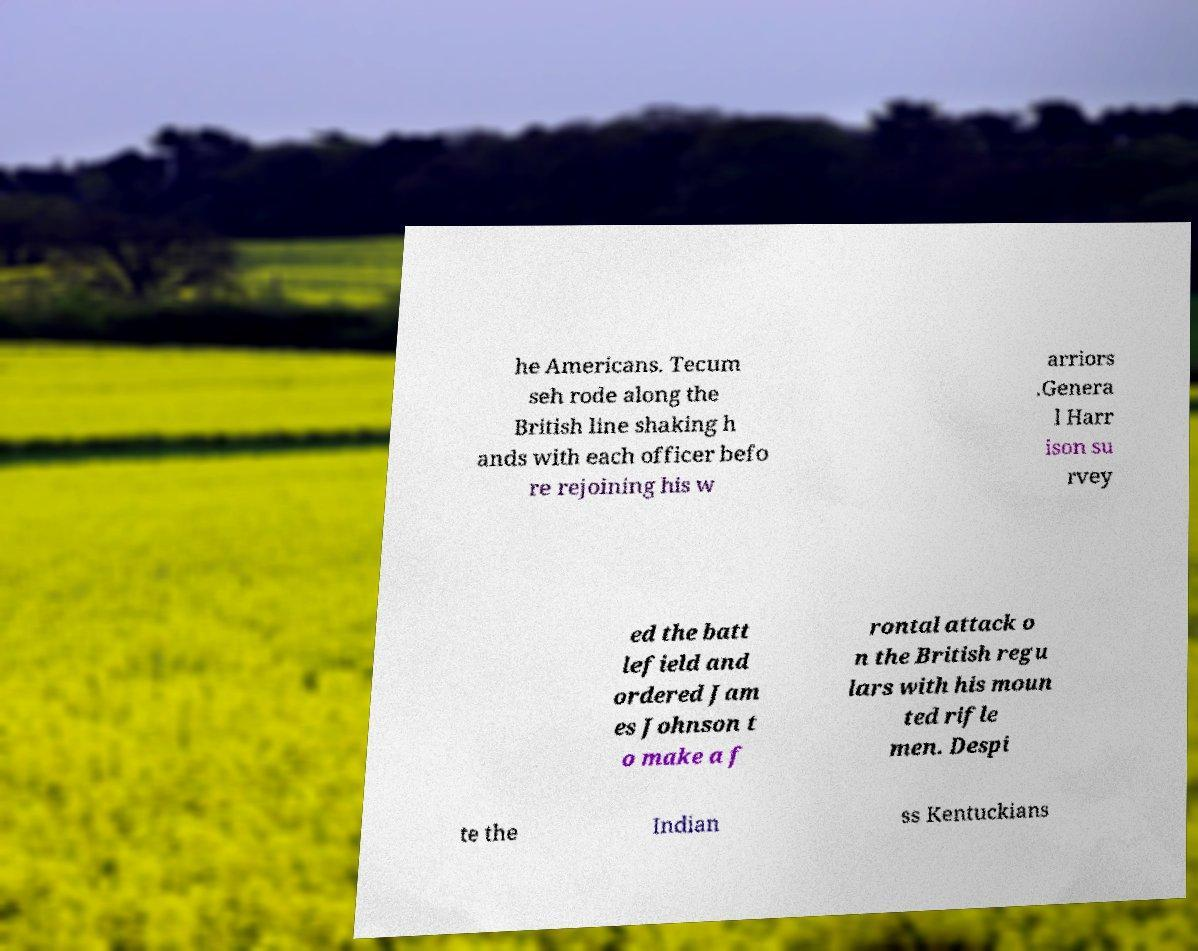Please read and relay the text visible in this image. What does it say? he Americans. Tecum seh rode along the British line shaking h ands with each officer befo re rejoining his w arriors .Genera l Harr ison su rvey ed the batt lefield and ordered Jam es Johnson t o make a f rontal attack o n the British regu lars with his moun ted rifle men. Despi te the Indian ss Kentuckians 